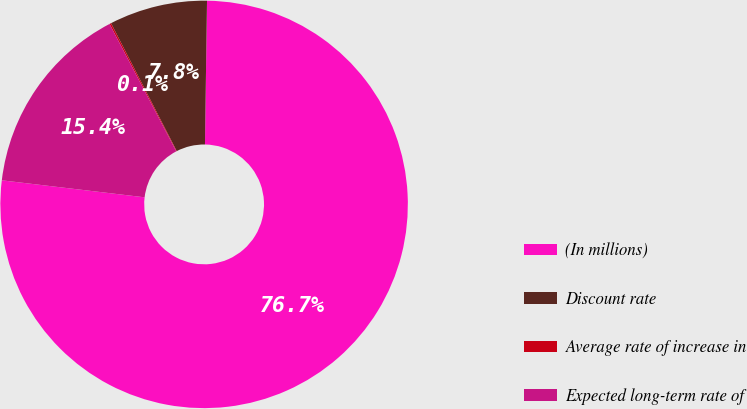Convert chart to OTSL. <chart><loc_0><loc_0><loc_500><loc_500><pie_chart><fcel>(In millions)<fcel>Discount rate<fcel>Average rate of increase in<fcel>Expected long-term rate of<nl><fcel>76.66%<fcel>7.78%<fcel>0.13%<fcel>15.43%<nl></chart> 